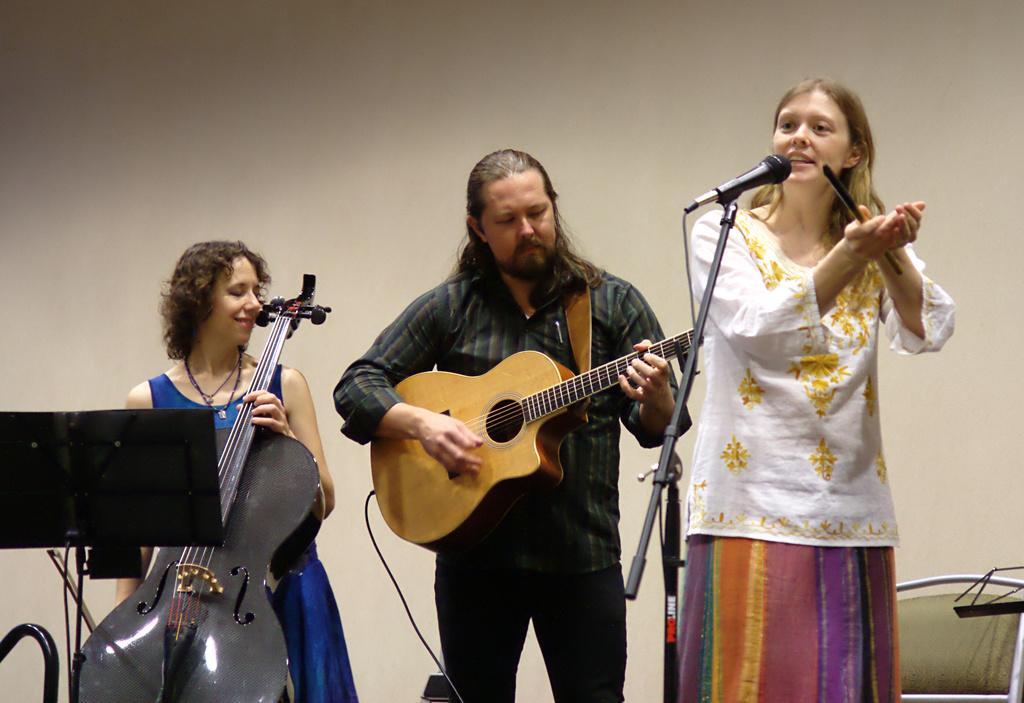Please provide a concise description of this image. Here in the right we can see a woman singing a song with a microphone in front of her and beside her we can see a man playing a guitar and beside him we can see a woman playing a violin 